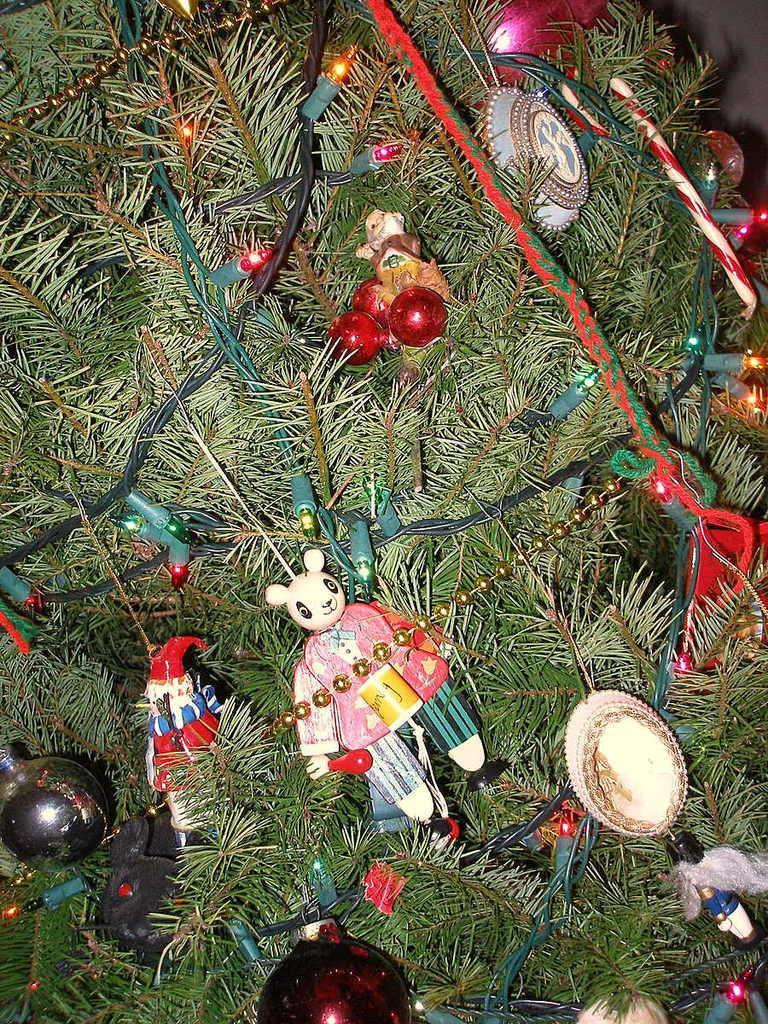In one or two sentences, can you explain what this image depicts? In this image I can see a Christmas tree in green color and I see few lights and multi color toys. 